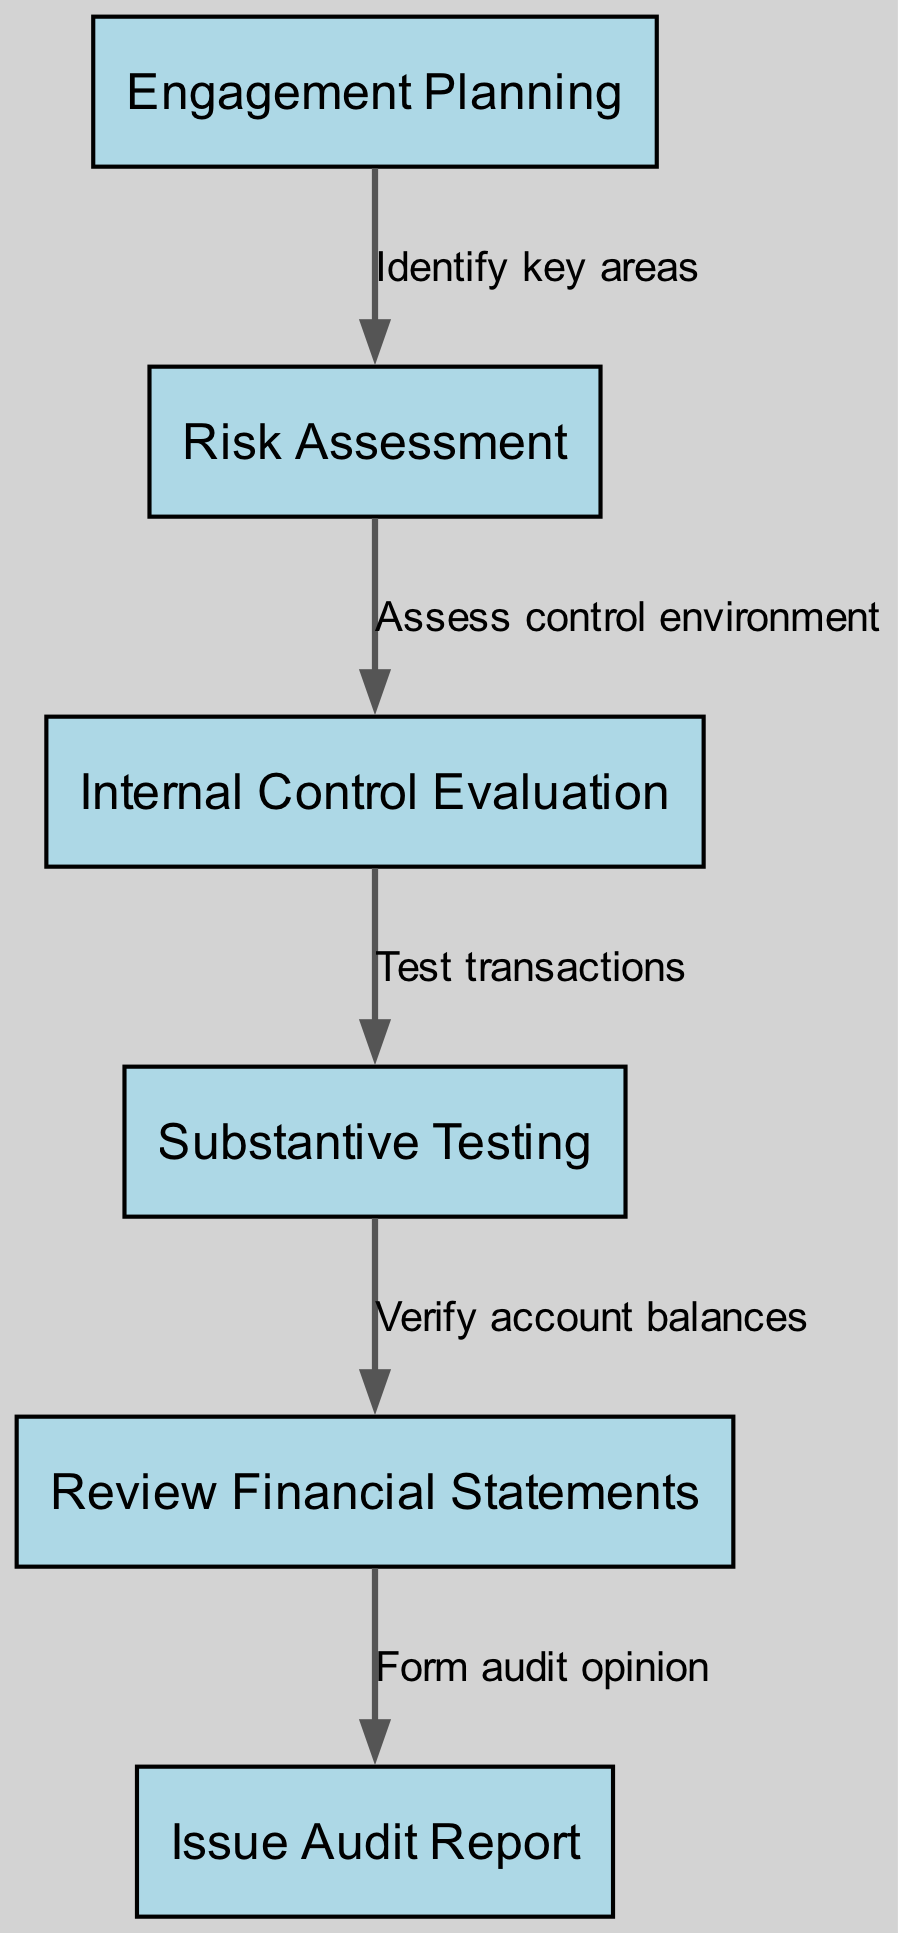What's the first step in the financial audit process? The diagram shows that "Engagement Planning" is the first step, indicated as the starting node.
Answer: Engagement Planning How many nodes are present in the diagram? By counting the nodes listed in the provided data, there are six distinct steps represented.
Answer: Six What is the label of the node connected to "Substantive Testing"? The edge from "Substantive Testing" leads to "Review Financial Statements," denoting the next step in the process.
Answer: Review Financial Statements Which node directly follows "Risk Assessment"? The flow from "Risk Assessment" leads to "Internal Control Evaluation," making that the immediate next step.
Answer: Internal Control Evaluation What label describes the action from "Engagement Planning" to "Risk Assessment"? The label on the edge between "Engagement Planning" and "Risk Assessment" indicates the action as "Identify key areas."
Answer: Identify key areas What is the last step in the audit procedure? The last node in the flow of the diagram is "Issue Audit Report," which completes the process of the financial audit.
Answer: Issue Audit Report Which step involves testing transactions? Looking at the process sequence, "Substantive Testing" is specifically focused on testing transactions as indicated in the flow.
Answer: Substantive Testing How does "Internal Control Evaluation" relate to "Risk Assessment"? The relationship is that "Internal Control Evaluation" directly follows "Risk Assessment," indicating a sequential evaluation process.
Answer: Directly follows What action is represented by the edge from "Review Financial Statements" to "Issue Audit Report"? The edge represents the action "Form audit opinion," showing the conclusion from reviewing the financials to issuing the report.
Answer: Form audit opinion 